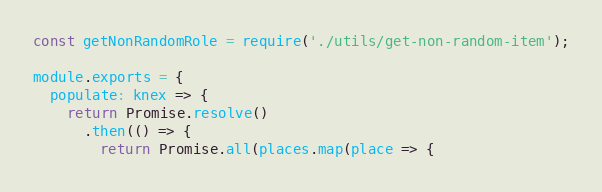Convert code to text. <code><loc_0><loc_0><loc_500><loc_500><_JavaScript_>const getNonRandomRole = require('./utils/get-non-random-item');

module.exports = {
  populate: knex => {
    return Promise.resolve()
      .then(() => {
        return Promise.all(places.map(place => {</code> 